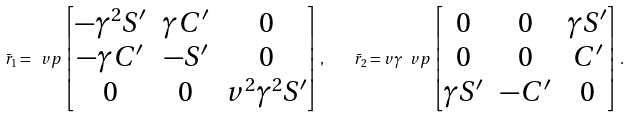Convert formula to latex. <formula><loc_0><loc_0><loc_500><loc_500>\bar { r } _ { 1 } = \ v p \begin{bmatrix} - \gamma ^ { 2 } S ^ { \prime } & \gamma C ^ { \prime } & 0 \\ - \gamma C ^ { \prime } & - S ^ { \prime } & 0 \\ 0 & 0 & v ^ { 2 } \gamma ^ { 2 } S ^ { \prime } \end{bmatrix} , \quad \bar { r } _ { 2 } = v \gamma \ v p \begin{bmatrix} 0 & 0 & \gamma S ^ { \prime } \\ 0 & 0 & C ^ { \prime } \\ \gamma S ^ { \prime } & - C ^ { \prime } & 0 \end{bmatrix} .</formula> 